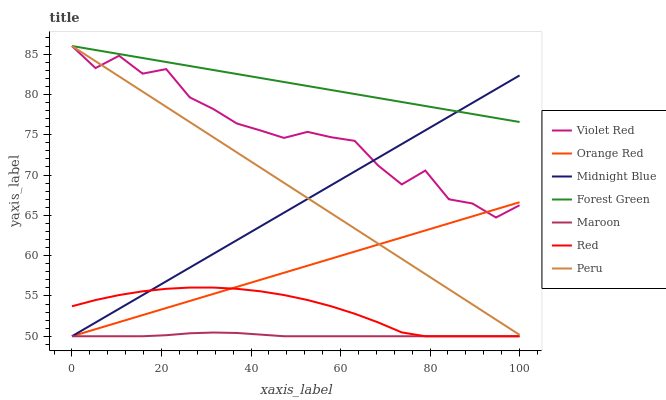Does Maroon have the minimum area under the curve?
Answer yes or no. Yes. Does Forest Green have the maximum area under the curve?
Answer yes or no. Yes. Does Midnight Blue have the minimum area under the curve?
Answer yes or no. No. Does Midnight Blue have the maximum area under the curve?
Answer yes or no. No. Is Midnight Blue the smoothest?
Answer yes or no. Yes. Is Violet Red the roughest?
Answer yes or no. Yes. Is Maroon the smoothest?
Answer yes or no. No. Is Maroon the roughest?
Answer yes or no. No. Does Midnight Blue have the lowest value?
Answer yes or no. Yes. Does Forest Green have the lowest value?
Answer yes or no. No. Does Peru have the highest value?
Answer yes or no. Yes. Does Midnight Blue have the highest value?
Answer yes or no. No. Is Maroon less than Forest Green?
Answer yes or no. Yes. Is Peru greater than Red?
Answer yes or no. Yes. Does Peru intersect Violet Red?
Answer yes or no. Yes. Is Peru less than Violet Red?
Answer yes or no. No. Is Peru greater than Violet Red?
Answer yes or no. No. Does Maroon intersect Forest Green?
Answer yes or no. No. 